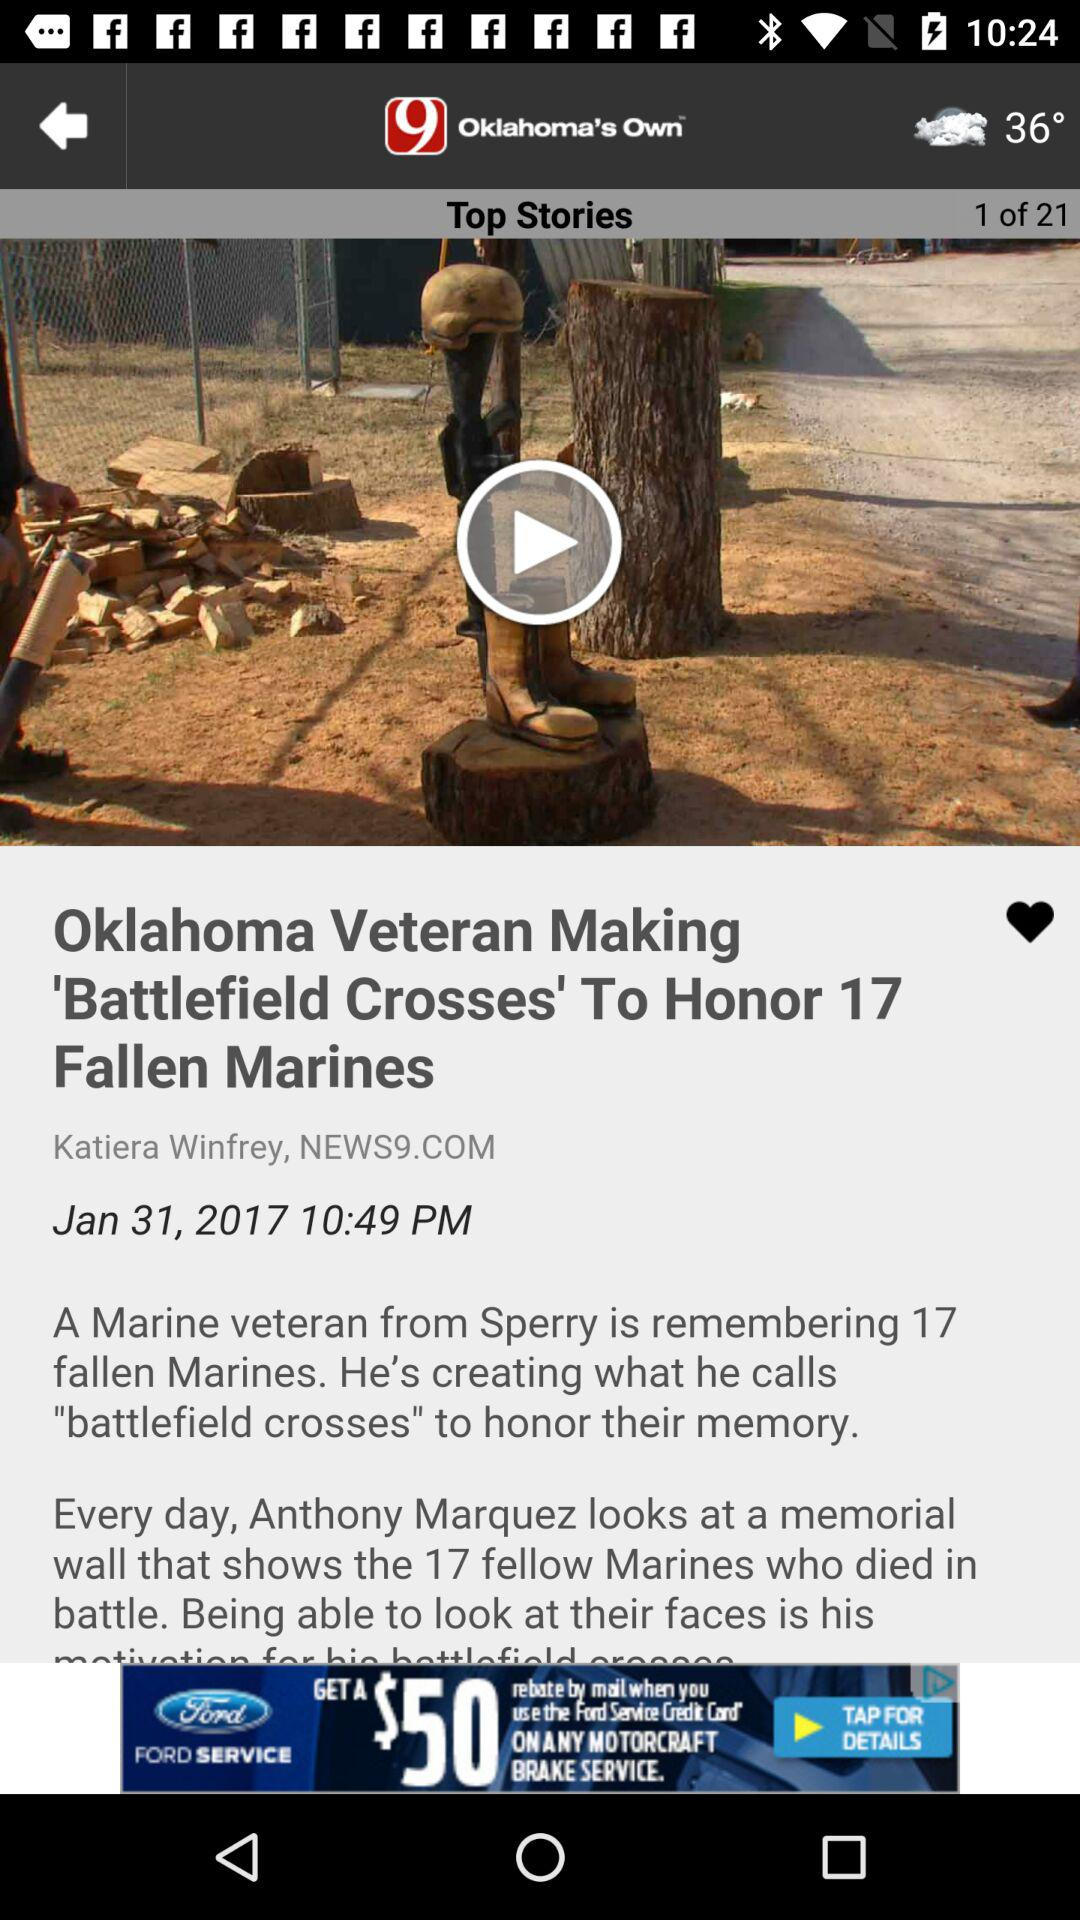What is the name of the author? The author name is Katiera Winfrey. 